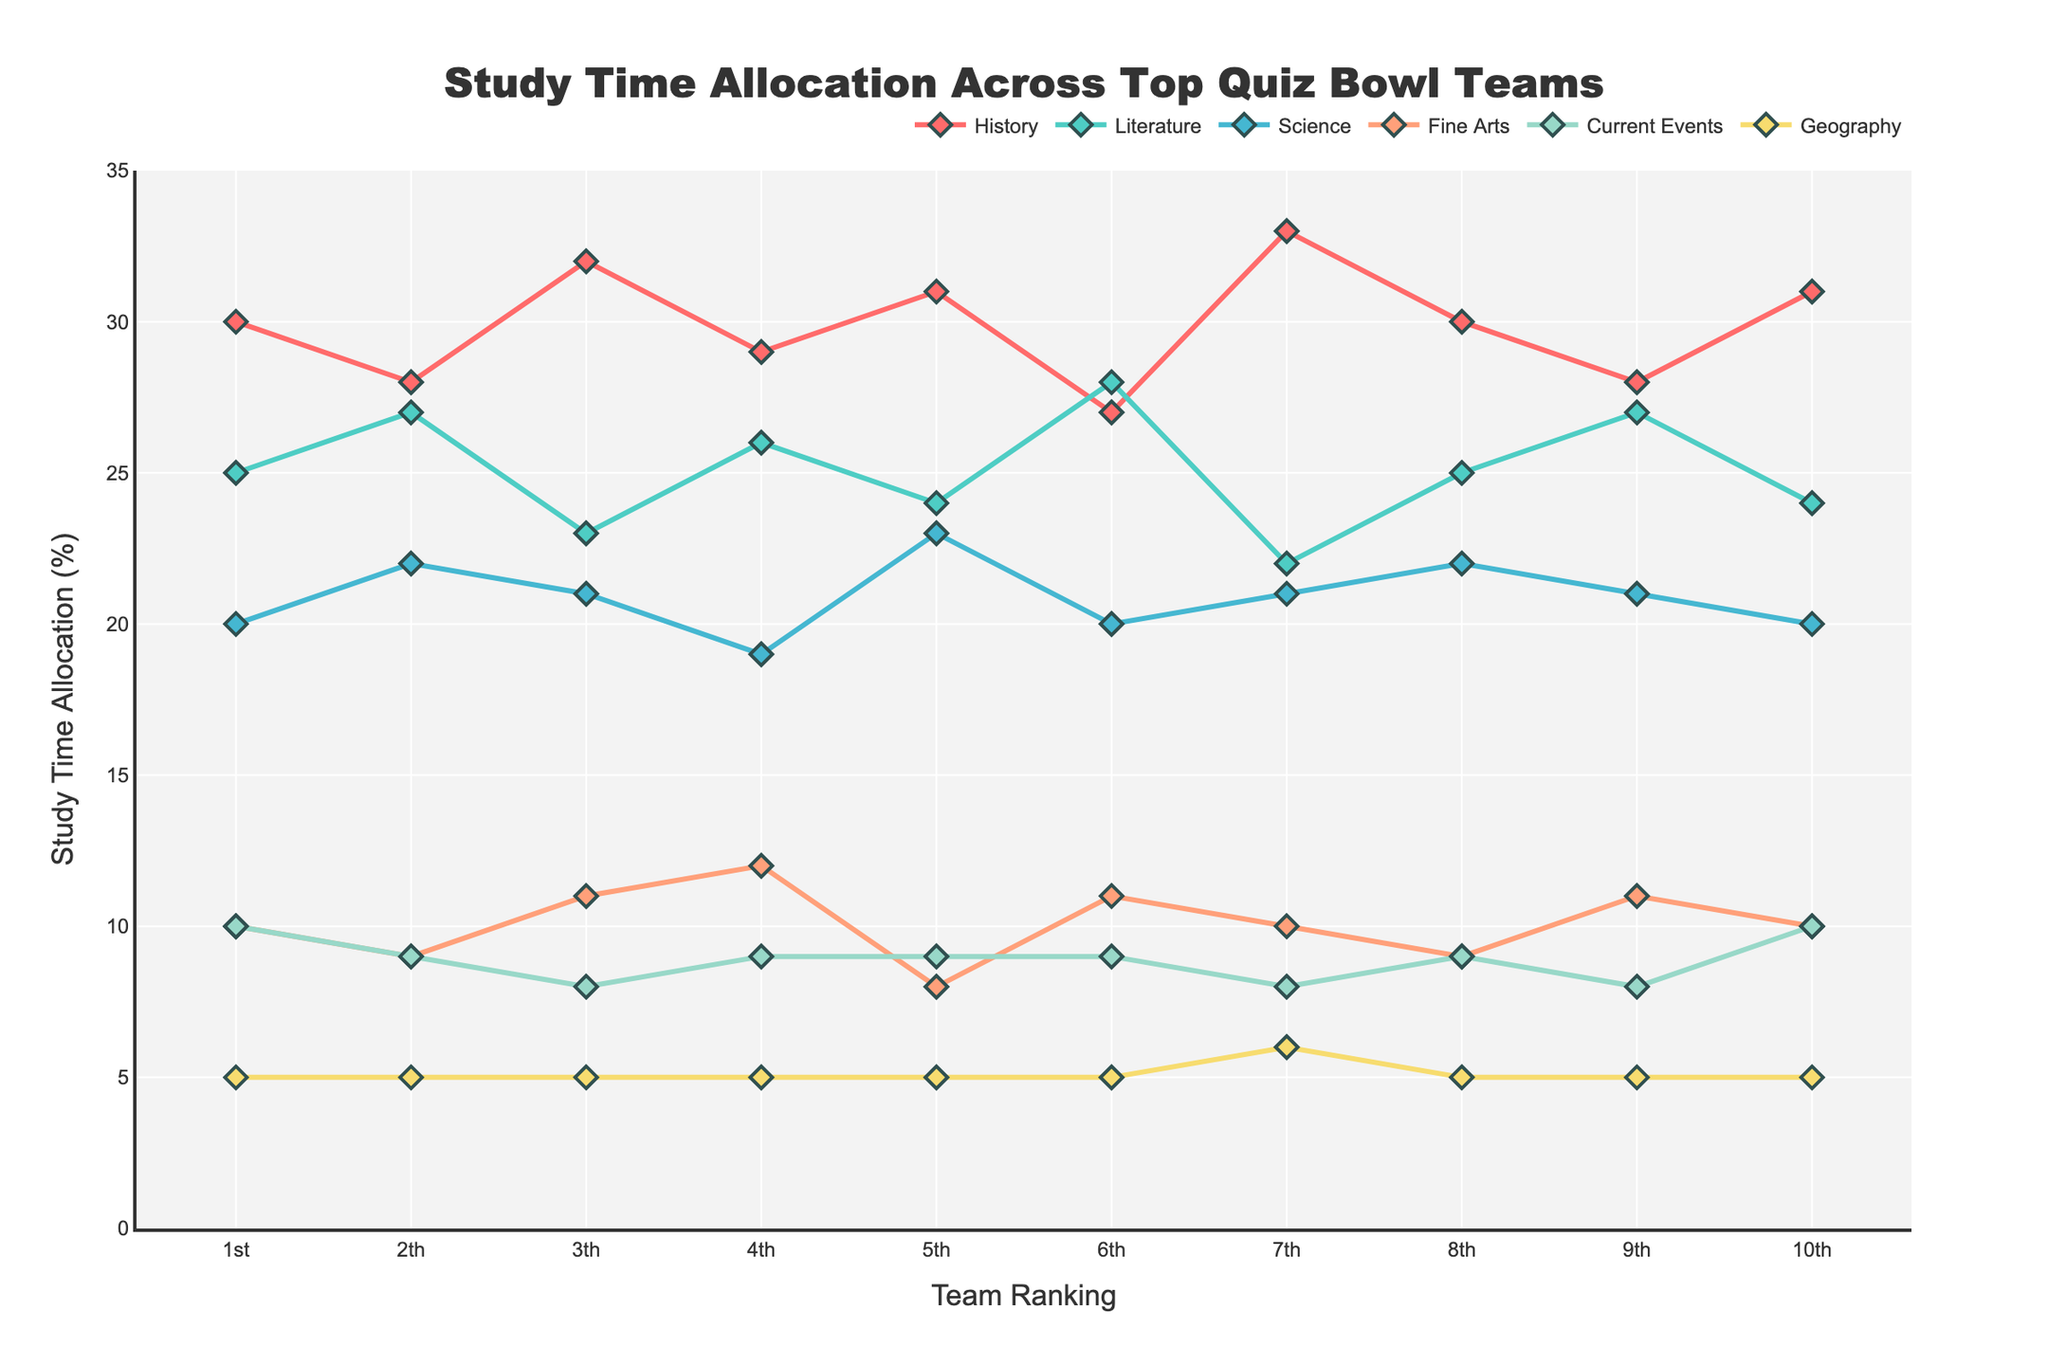Which team allocated the most study time to History? By observing the highest point of the line representing History, we can identify that the 7th Place Team has the highest allocation for this subject at 33%.
Answer: 7th Place Team Which subject has the most consistently allocated time across all teams? By examining the lines, the Geography line appears to be the most consistent across all teams, with all teams allocating exactly 5%.
Answer: Geography What's the total study time allocation for the top two teams in Literature? The 1st Place Team allocated 25% and the 2nd Place Team allocated 27%. Summing these gives 25% + 27% = 52%.
Answer: 52% Which team had the least variation in study time allocation across all subjects? By observing the slopes and range of the lines for each team, the 6th Place Team shows the least variation, with close percentages across different subjects.
Answer: 6th Place Team What is the average study time allocation for Science among the top three teams? The 1st, 2nd, and 3rd Place Teams allocated 20%, 22%, and 21% respectively. The average is calculated as (20 + 22 + 21) / 3 = 21%.
Answer: 21% For the 3rd Place Team, how much more time do they allocate to History compared to Current Events? The 3rd Place Team allocated 32% to History and 8% to Current Events. Therefore, the difference is 32% - 8% = 24%.
Answer: 24% Which subject received the least study time allocation from the 5th Place Team? Observing the lines, Fine Arts received 8% from the 5th Place Team, which is the lowest allocation for that team.
Answer: Fine Arts Compare the study time allocation for Current Events between the 1st Place Team and the 4th Place Team. The 1st Place Team allocated 10% to Current Events, while the 4th Place Team allocated 9%. Therefore, the 1st Place Team allocated 1% more.
Answer: 1% What's the difference in study time allocation for Fine Arts between the 1st Place Team and the 10th Place Team? Both the 1st Place Team and the 10th Place Team allocated 10% to Fine Arts, so the difference is 0%.
Answer: 0% Which team allocated the most study time to Fine Arts and how much? By observing the highest point of the line representing Fine Arts, the 4th Place Team allocated the most time at 12%.
Answer: 4th Place Team 